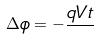<formula> <loc_0><loc_0><loc_500><loc_500>\Delta \phi = - \frac { q V t } { }</formula> 